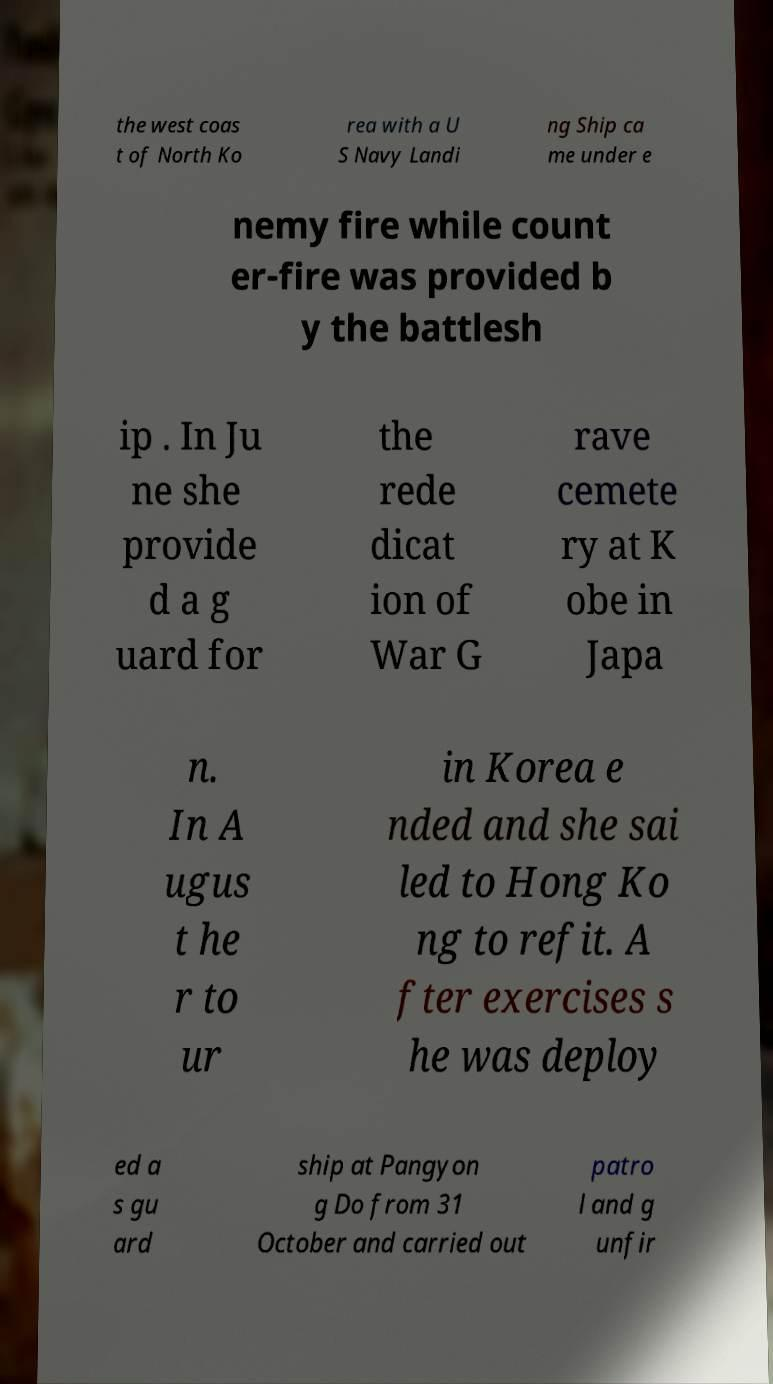There's text embedded in this image that I need extracted. Can you transcribe it verbatim? the west coas t of North Ko rea with a U S Navy Landi ng Ship ca me under e nemy fire while count er-fire was provided b y the battlesh ip . In Ju ne she provide d a g uard for the rede dicat ion of War G rave cemete ry at K obe in Japa n. In A ugus t he r to ur in Korea e nded and she sai led to Hong Ko ng to refit. A fter exercises s he was deploy ed a s gu ard ship at Pangyon g Do from 31 October and carried out patro l and g unfir 